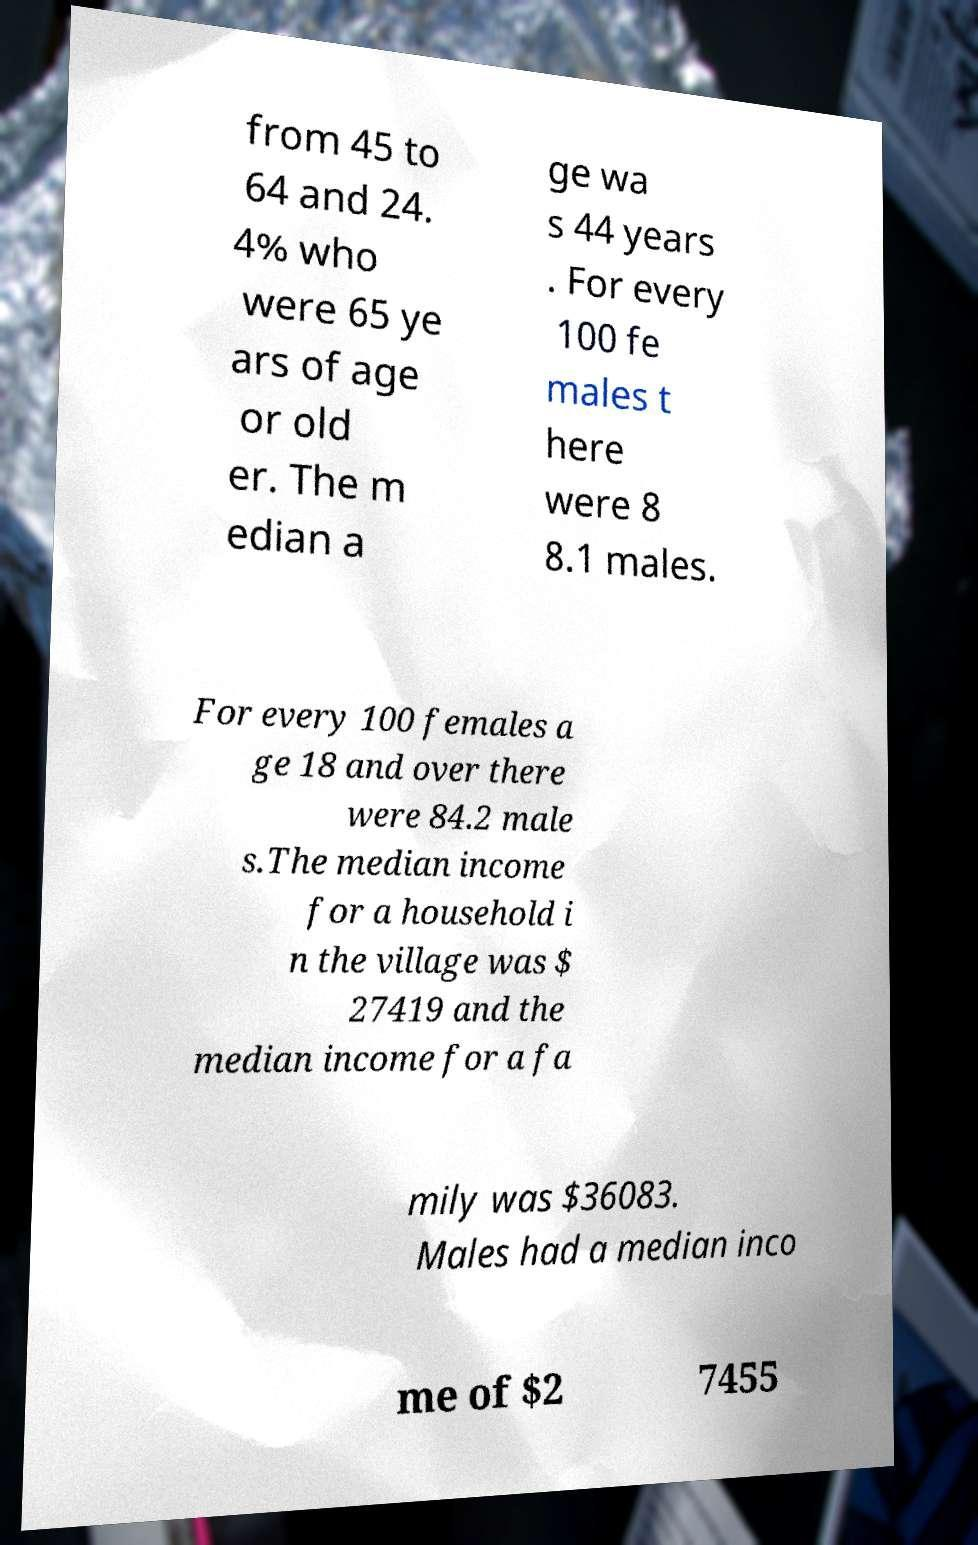I need the written content from this picture converted into text. Can you do that? from 45 to 64 and 24. 4% who were 65 ye ars of age or old er. The m edian a ge wa s 44 years . For every 100 fe males t here were 8 8.1 males. For every 100 females a ge 18 and over there were 84.2 male s.The median income for a household i n the village was $ 27419 and the median income for a fa mily was $36083. Males had a median inco me of $2 7455 